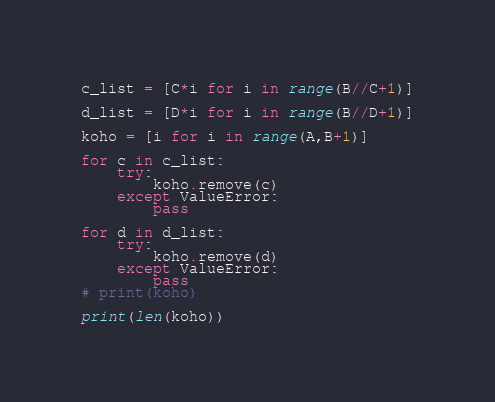<code> <loc_0><loc_0><loc_500><loc_500><_Python_>c_list = [C*i for i in range(B//C+1)]

d_list = [D*i for i in range(B//D+1)]

koho = [i for i in range(A,B+1)]

for c in c_list:
    try:
        koho.remove(c)
    except ValueError:
        pass

for d in d_list:
    try:
        koho.remove(d)
    except ValueError:
        pass
# print(koho)

print(len(koho))</code> 